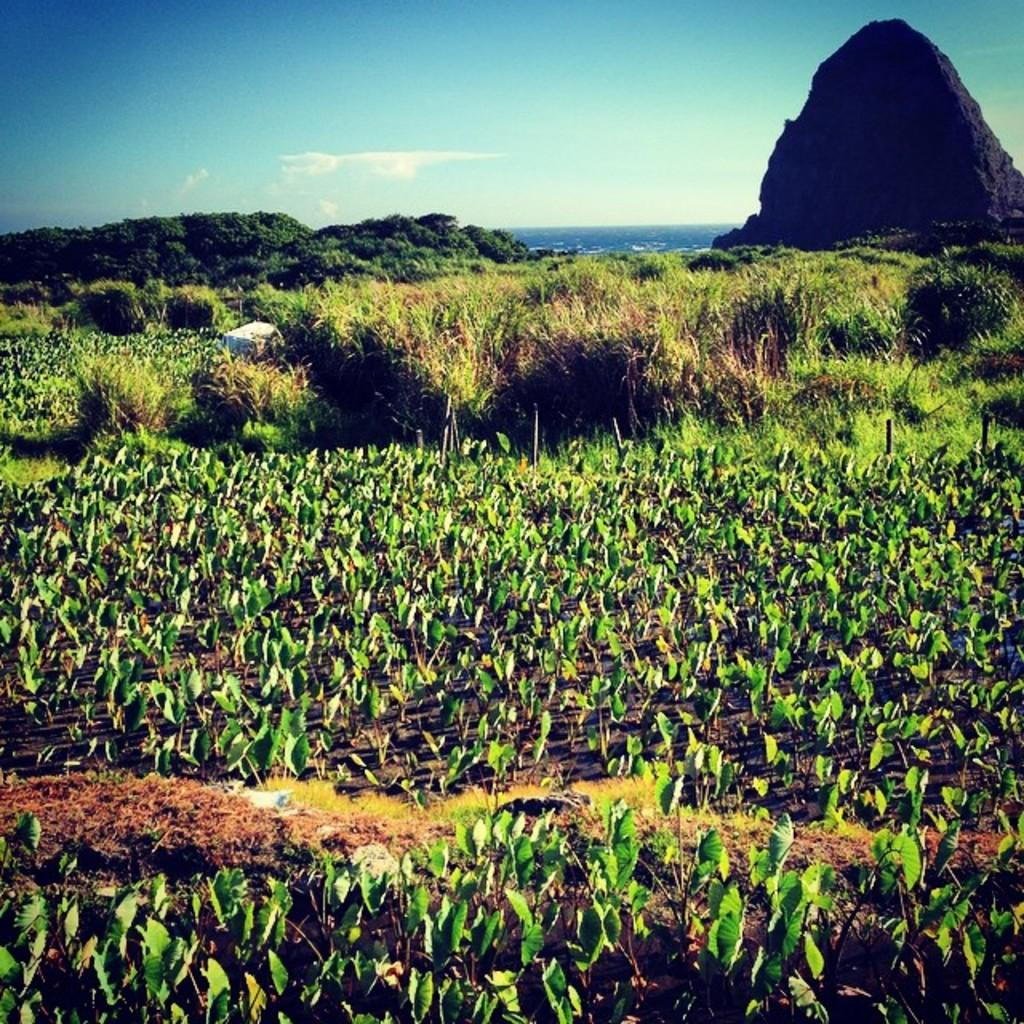What type of vegetation or plants can be seen in the foreground of the image? There is greenery in the foreground of the image. What type of natural feature is visible in the background of the image? There is a mountain in the background of the image. What else can be seen in the background of the image besides the mountain? The sky is visible in the background of the image. Is there a cave visible in the image? There is no cave present in the image. Can you see a person walking in the image? There is no person visible in the image. 